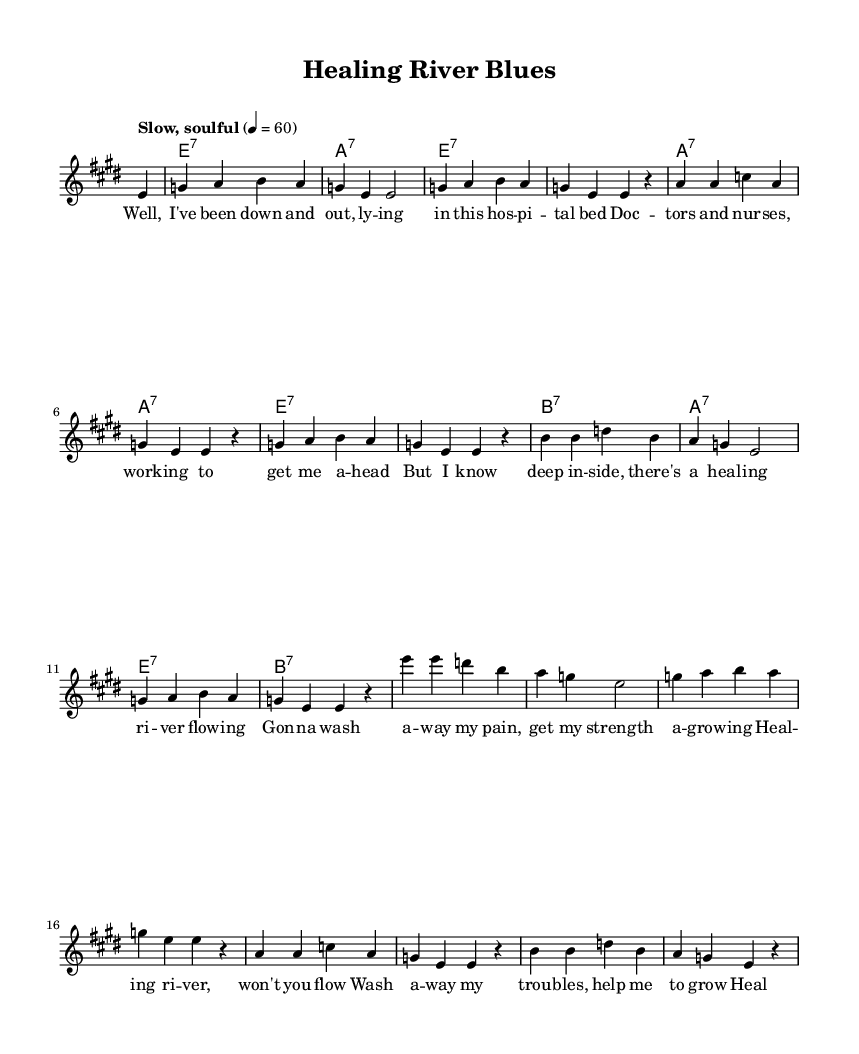What is the key signature of this music? The key signature is E major, which has four sharps (F#, C#, G#, D#).
Answer: E major What is the time signature of this music? The time signature is 4/4, indicating that there are four beats per measure.
Answer: 4/4 What is the tempo marking for this piece? The tempo marking is "Slow, soulful," which suggests a relaxed pace.
Answer: Slow, soulful How many verses are in the lyrics? The lyrics consist of two verses, separated by the repeated refrain.
Answer: Two verses What is the chord associated with the first measure? The chord associated with the first measure is E7, as indicated by the chord symbol.
Answer: E7 What themes are explored in the lyrics? The lyrics explore themes of healing and recovery, focusing on overcoming pain and gaining strength.
Answer: Healing and recovery Which musical form is indicated by the repetition of lines in the lyrics? The musical form is a typical blues structure, often featuring repeated phrases and refrains.
Answer: Blues structure 